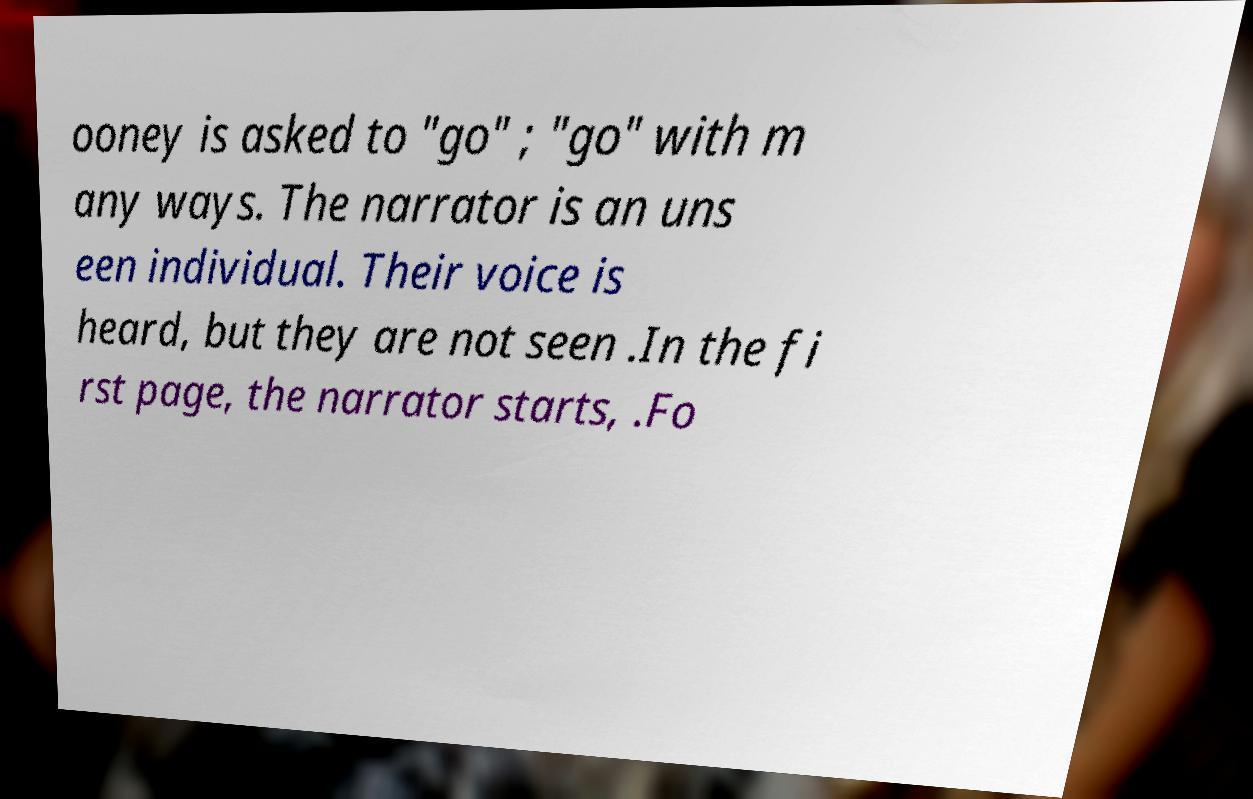I need the written content from this picture converted into text. Can you do that? ooney is asked to "go" ; "go" with m any ways. The narrator is an uns een individual. Their voice is heard, but they are not seen .In the fi rst page, the narrator starts, .Fo 